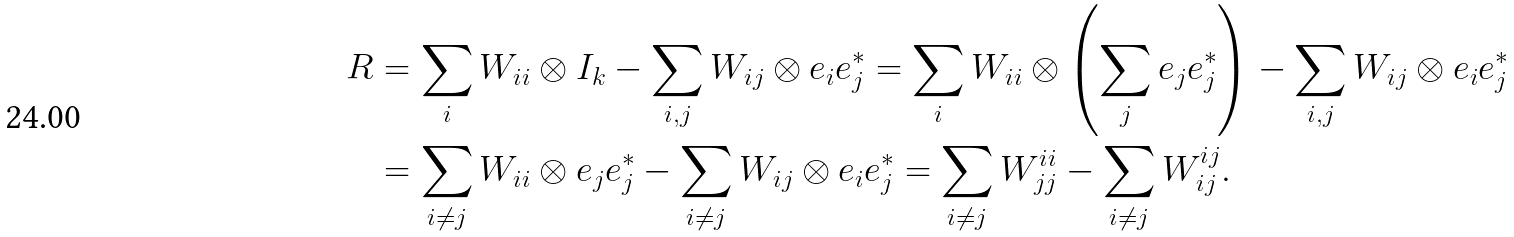Convert formula to latex. <formula><loc_0><loc_0><loc_500><loc_500>R & = \sum _ { i } W _ { i i } \otimes I _ { k } - \sum _ { i , j } W _ { i j } \otimes e _ { i } e _ { j } ^ { * } = \sum _ { i } W _ { i i } \otimes \left ( \sum _ { j } e _ { j } e _ { j } ^ { * } \right ) - \sum _ { i , j } W _ { i j } \otimes e _ { i } e _ { j } ^ { * } \\ & = \sum _ { i \neq j } W _ { i i } \otimes e _ { j } e _ { j } ^ { * } - \sum _ { i \neq j } W _ { i j } \otimes e _ { i } e _ { j } ^ { * } = \sum _ { i \neq j } W _ { j j } ^ { i i } - \sum _ { i \neq j } W _ { i j } ^ { i j } .</formula> 